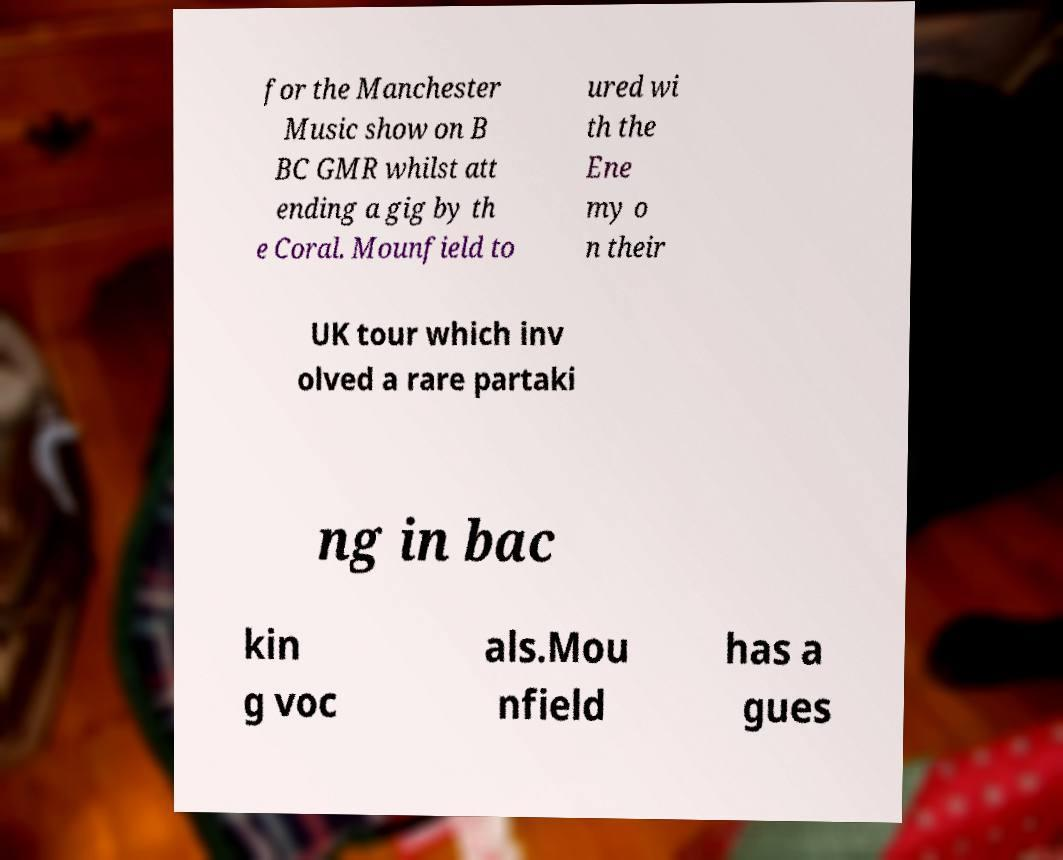I need the written content from this picture converted into text. Can you do that? for the Manchester Music show on B BC GMR whilst att ending a gig by th e Coral. Mounfield to ured wi th the Ene my o n their UK tour which inv olved a rare partaki ng in bac kin g voc als.Mou nfield has a gues 